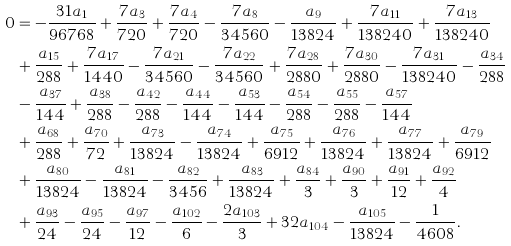<formula> <loc_0><loc_0><loc_500><loc_500>0 & = - \frac { 3 1 a _ { 1 } } { 9 6 7 6 8 } + \frac { 7 a _ { 3 } } { 7 2 0 } + \frac { 7 a _ { 4 } } { 7 2 0 } - \frac { 7 a _ { 8 } } { 3 4 5 6 0 } - \frac { a _ { 9 } } { 1 3 8 2 4 } + \frac { 7 a _ { 1 1 } } { 1 3 8 2 4 0 } + \frac { 7 a _ { 1 3 } } { 1 3 8 2 4 0 } \\ & + \frac { a _ { 1 5 } } { 2 8 8 } + \frac { 7 a _ { 1 7 } } { 1 4 4 0 } - \frac { 7 a _ { 2 1 } } { 3 4 5 6 0 } - \frac { 7 a _ { 2 2 } } { 3 4 5 6 0 } + \frac { 7 a _ { 2 8 } } { 2 8 8 0 } + \frac { 7 a _ { 3 0 } } { 2 8 8 0 } - \frac { 7 a _ { 3 1 } } { 1 3 8 2 4 0 } - \frac { a _ { 3 4 } } { 2 8 8 } \\ & - \frac { a _ { 3 7 } } { 1 4 4 } + \frac { a _ { 3 8 } } { 2 8 8 } - \frac { a _ { 4 2 } } { 2 8 8 } - \frac { a _ { 4 4 } } { 1 4 4 } - \frac { a _ { 5 3 } } { 1 4 4 } - \frac { a _ { 5 4 } } { 2 8 8 } - \frac { a _ { 5 5 } } { 2 8 8 } - \frac { a _ { 5 7 } } { 1 4 4 } \\ & + \frac { a _ { 6 8 } } { 2 8 8 } + \frac { a _ { 7 0 } } { 7 2 } + \frac { a _ { 7 3 } } { 1 3 8 2 4 } - \frac { a _ { 7 4 } } { 1 3 8 2 4 } + \frac { a _ { 7 5 } } { 6 9 1 2 } + \frac { a _ { 7 6 } } { 1 3 8 2 4 } + \frac { a _ { 7 7 } } { 1 3 8 2 4 } + \frac { a _ { 7 9 } } { 6 9 1 2 } \\ & + \frac { a _ { 8 0 } } { 1 3 8 2 4 } - \frac { a _ { 8 1 } } { 1 3 8 2 4 } - \frac { a _ { 8 2 } } { 3 4 5 6 } + \frac { a _ { 8 3 } } { 1 3 8 2 4 } + \frac { a _ { 8 4 } } { 3 } + \frac { a _ { 9 0 } } { 3 } + \frac { a _ { 9 1 } } { 1 2 } + \frac { a _ { 9 2 } } { 4 } \\ & + \frac { a _ { 9 3 } } { 2 4 } - \frac { a _ { 9 5 } } { 2 4 } - \frac { a _ { 9 7 } } { 1 2 } - \frac { a _ { 1 0 2 } } { 6 } - \frac { 2 a _ { 1 0 3 } } { 3 } + 3 2 a _ { 1 0 4 } - \frac { a _ { 1 0 5 } } { 1 3 8 2 4 } - \frac { 1 } { 4 6 0 8 } .</formula> 